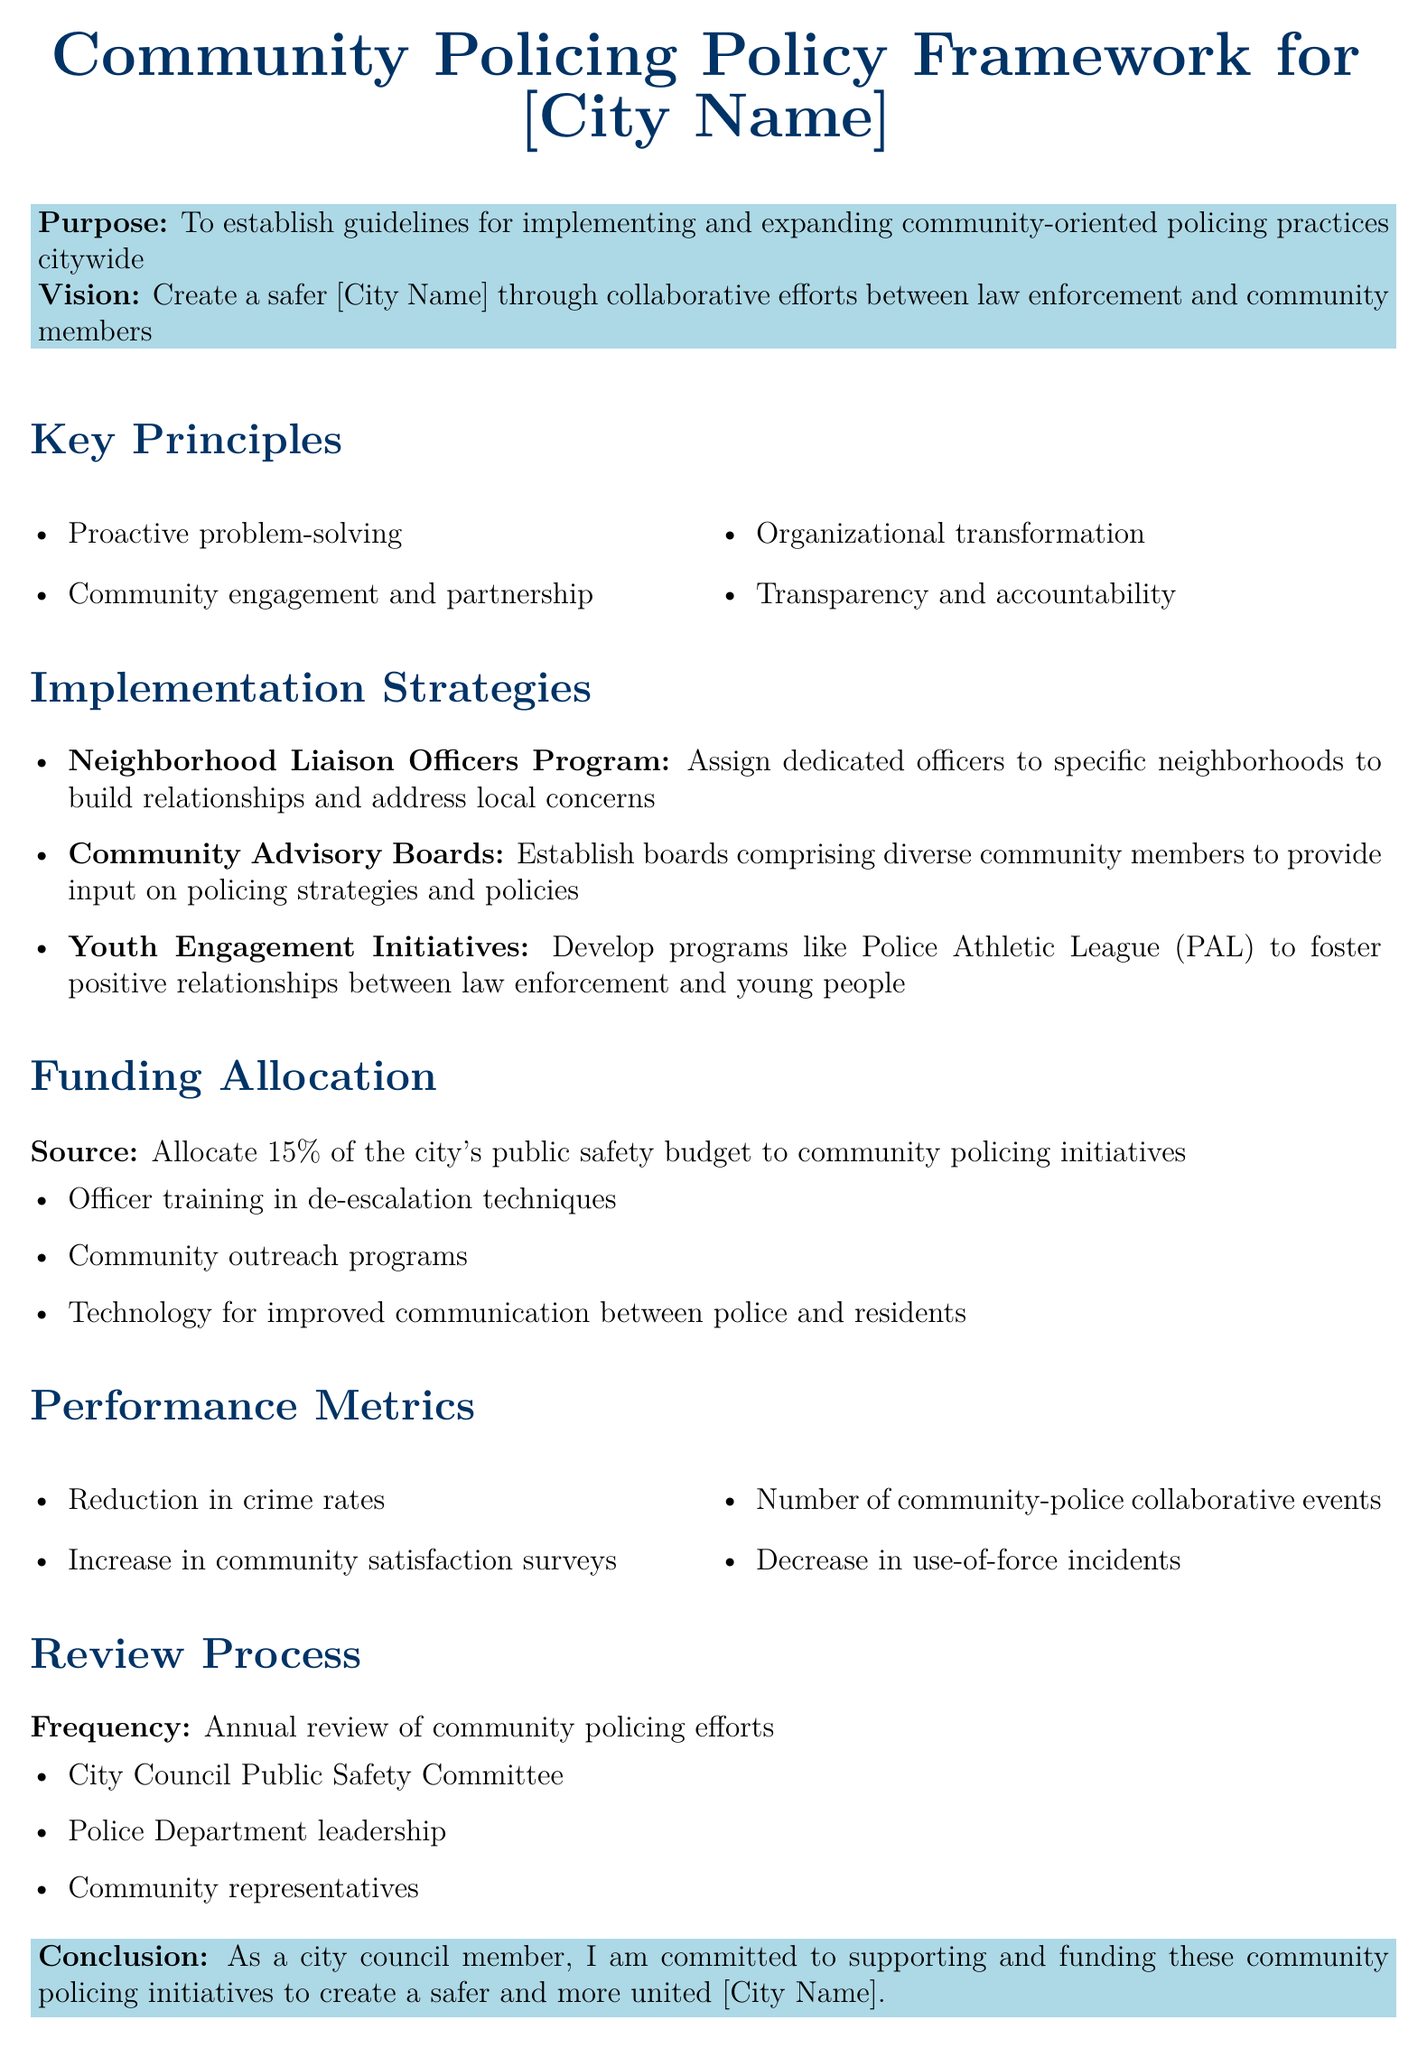What is the purpose of the document? The purpose is to establish guidelines for implementing and expanding community-oriented policing practices citywide.
Answer: To establish guidelines for implementing and expanding community-oriented policing practices citywide What percentage of the city's public safety budget is allocated to community policing initiatives? The document states a specific allocation from the budget for community policing.
Answer: 15% What program is designed for youth engagement? This program aims to foster positive relationships between law enforcement and young people in the community.
Answer: Police Athletic League (PAL) Who is involved in the annual review process of community policing efforts? The document lists entities that will review community policing efforts annually.
Answer: City Council Public Safety Committee, Police Department leadership, Community representatives What is one of the key principles mentioned in the policy framework? The document enumerates principles guiding the community policing approach.
Answer: Proactive problem-solving How often will the community policing efforts be reviewed? This refers to the frequency established in the policy for evaluations.
Answer: Annual 